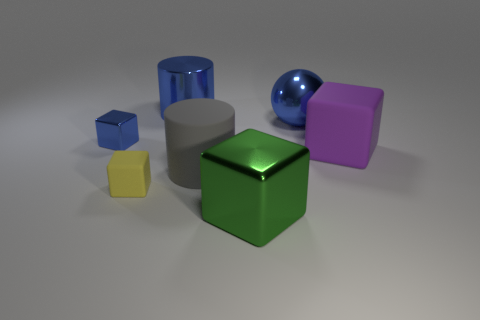Add 3 tiny shiny cubes. How many objects exist? 10 Subtract all balls. How many objects are left? 6 Subtract 0 brown balls. How many objects are left? 7 Subtract all large blocks. Subtract all large metallic objects. How many objects are left? 2 Add 5 large gray things. How many large gray things are left? 6 Add 1 small yellow blocks. How many small yellow blocks exist? 2 